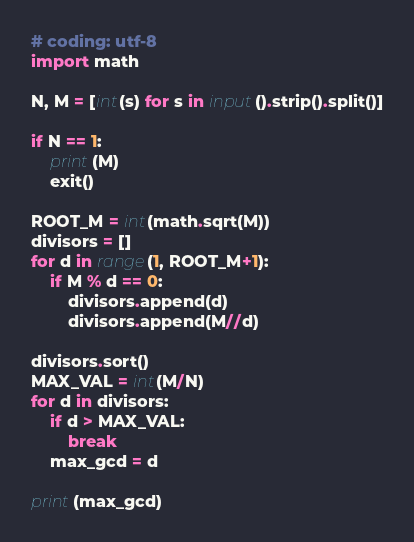<code> <loc_0><loc_0><loc_500><loc_500><_Python_># coding: utf-8
import math

N, M = [int(s) for s in input().strip().split()]

if N == 1:
    print(M)
    exit()

ROOT_M = int(math.sqrt(M))
divisors = []
for d in range(1, ROOT_M+1):
    if M % d == 0:
        divisors.append(d)
        divisors.append(M//d)

divisors.sort()
MAX_VAL = int(M/N)
for d in divisors:
    if d > MAX_VAL:
        break
    max_gcd = d

print(max_gcd)
</code> 